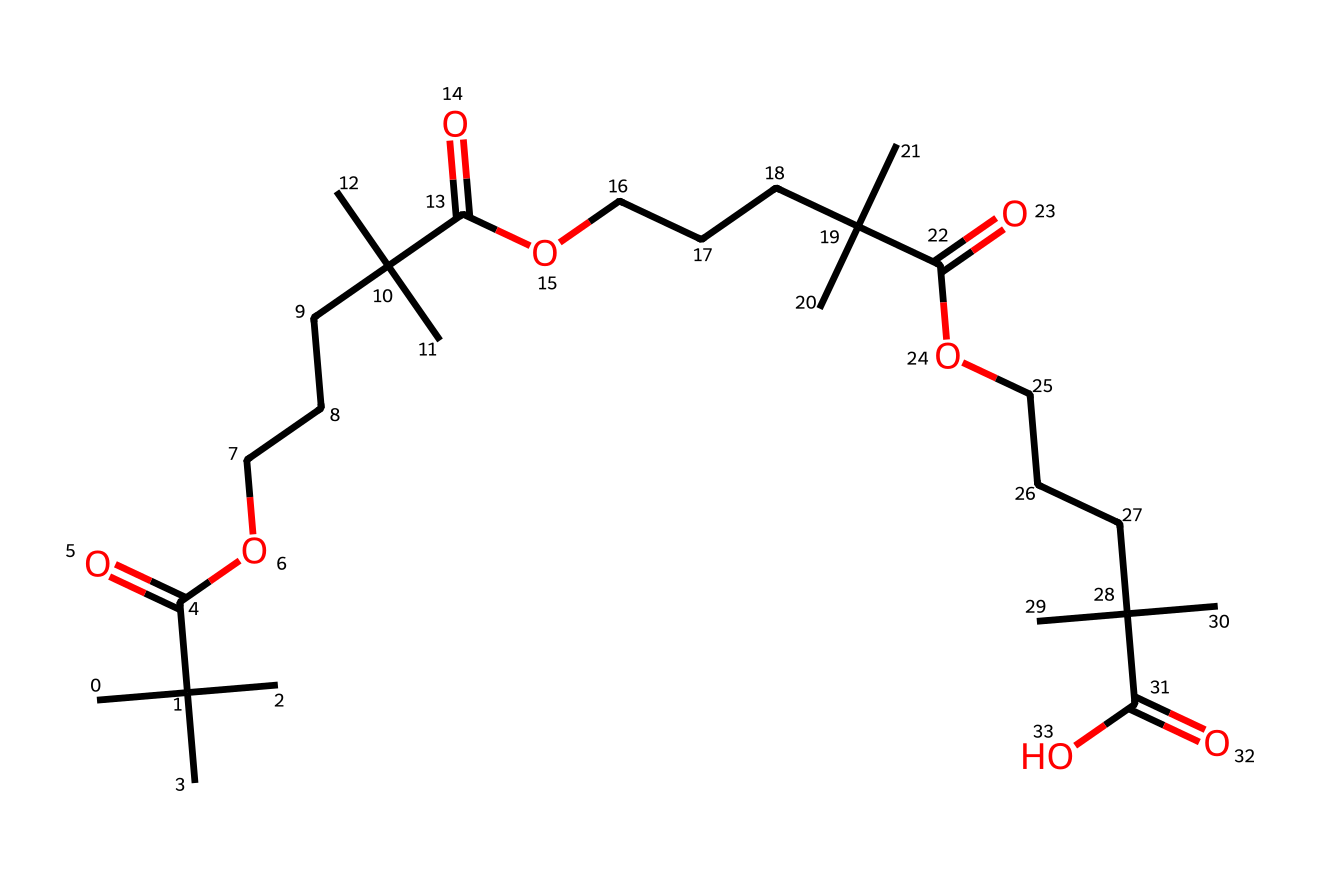how many carboxylic acid groups are present in this structure? The given SMILES representation displays multiple occurrences of "C(=O)O", indicating the presence of carboxylic acid groups. By counting these occurrences, we see there are four such groups in the structure.
Answer: four what is the backbone structure of this polymer? The SMILES indicates a repeating unit structure with a backbone made up of carbon chains. The CCCCC segments show long carbon chains, linked by functional groups like carboxylic acid.
Answer: carbon chains what type of polymer is represented by this structure? The repetitive carboxylic acid groups and aliphatic carbon chain suggest it is a polyester, specifically formed by the reaction between a diol and dicarboxylic acid.
Answer: polyester what functional group is prominently featured in this polymer? The presence of "C(=O)O" in the SMILES structure indicates that the functional group is a carboxylic acid, which is integral to the polymer's composition.
Answer: carboxylic acid how many total carbon atoms are in this polymer structure? Each occurrence of "C" represents a carbon atom. By counting every "C" in the SMILES, and considering that the structure is symmetrical and repetitive, there are 36 carbon atoms.
Answer: thirty-six what type of solid is produced from this polymer? Given the structure includes multiple alkyl groups attached to the polymer backbone, this solid generally exhibits properties of elastomers, which can provide flexibility.
Answer: elastomer 